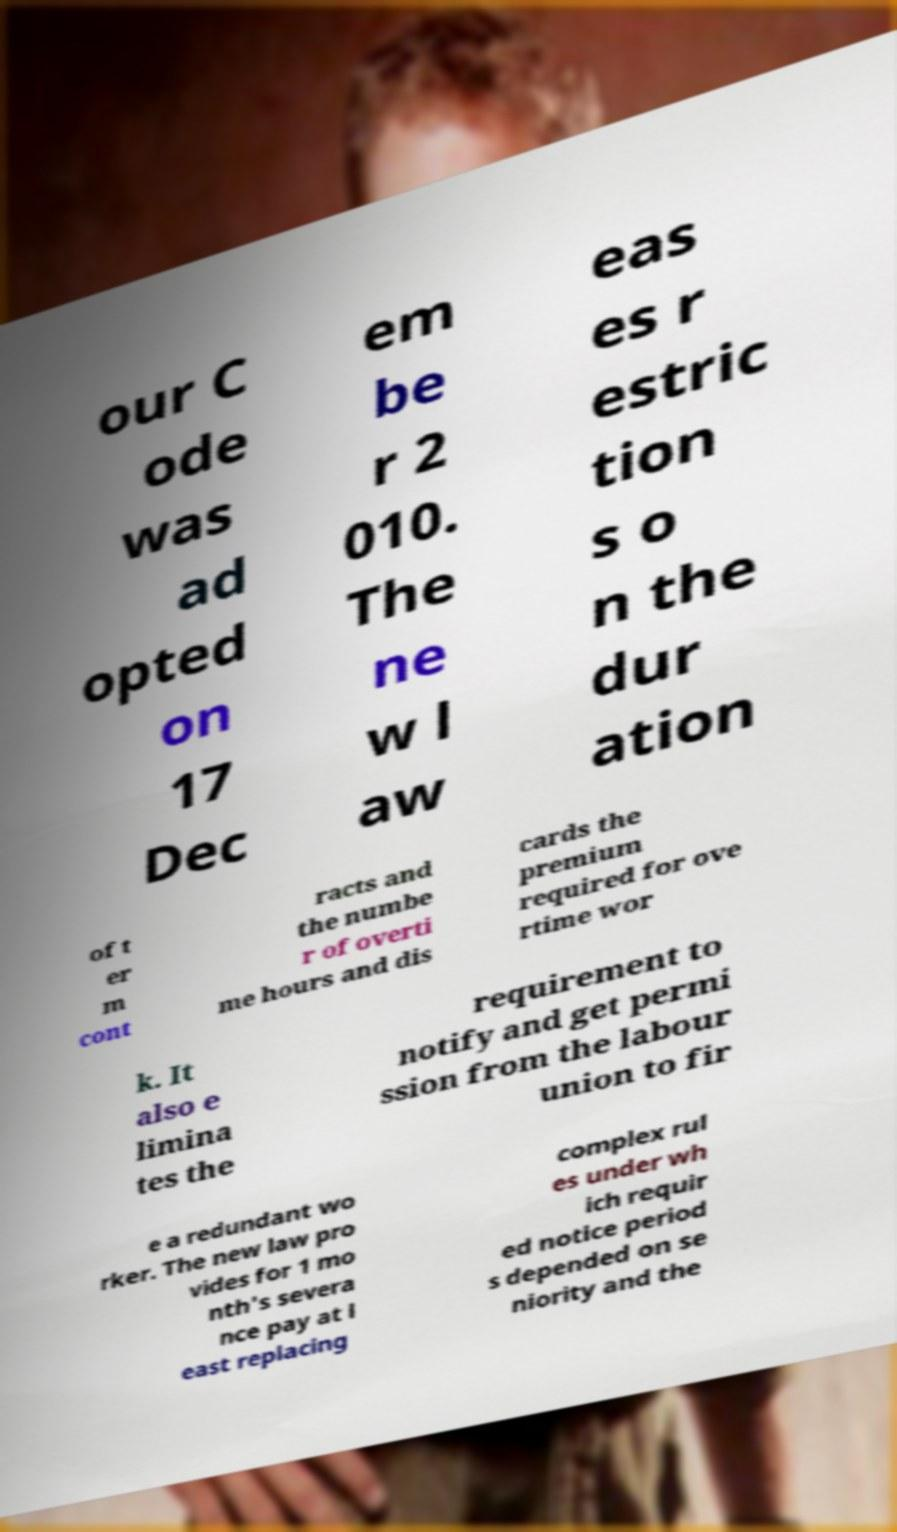Can you accurately transcribe the text from the provided image for me? our C ode was ad opted on 17 Dec em be r 2 010. The ne w l aw eas es r estric tion s o n the dur ation of t er m cont racts and the numbe r of overti me hours and dis cards the premium required for ove rtime wor k. It also e limina tes the requirement to notify and get permi ssion from the labour union to fir e a redundant wo rker. The new law pro vides for 1 mo nth's severa nce pay at l east replacing complex rul es under wh ich requir ed notice period s depended on se niority and the 